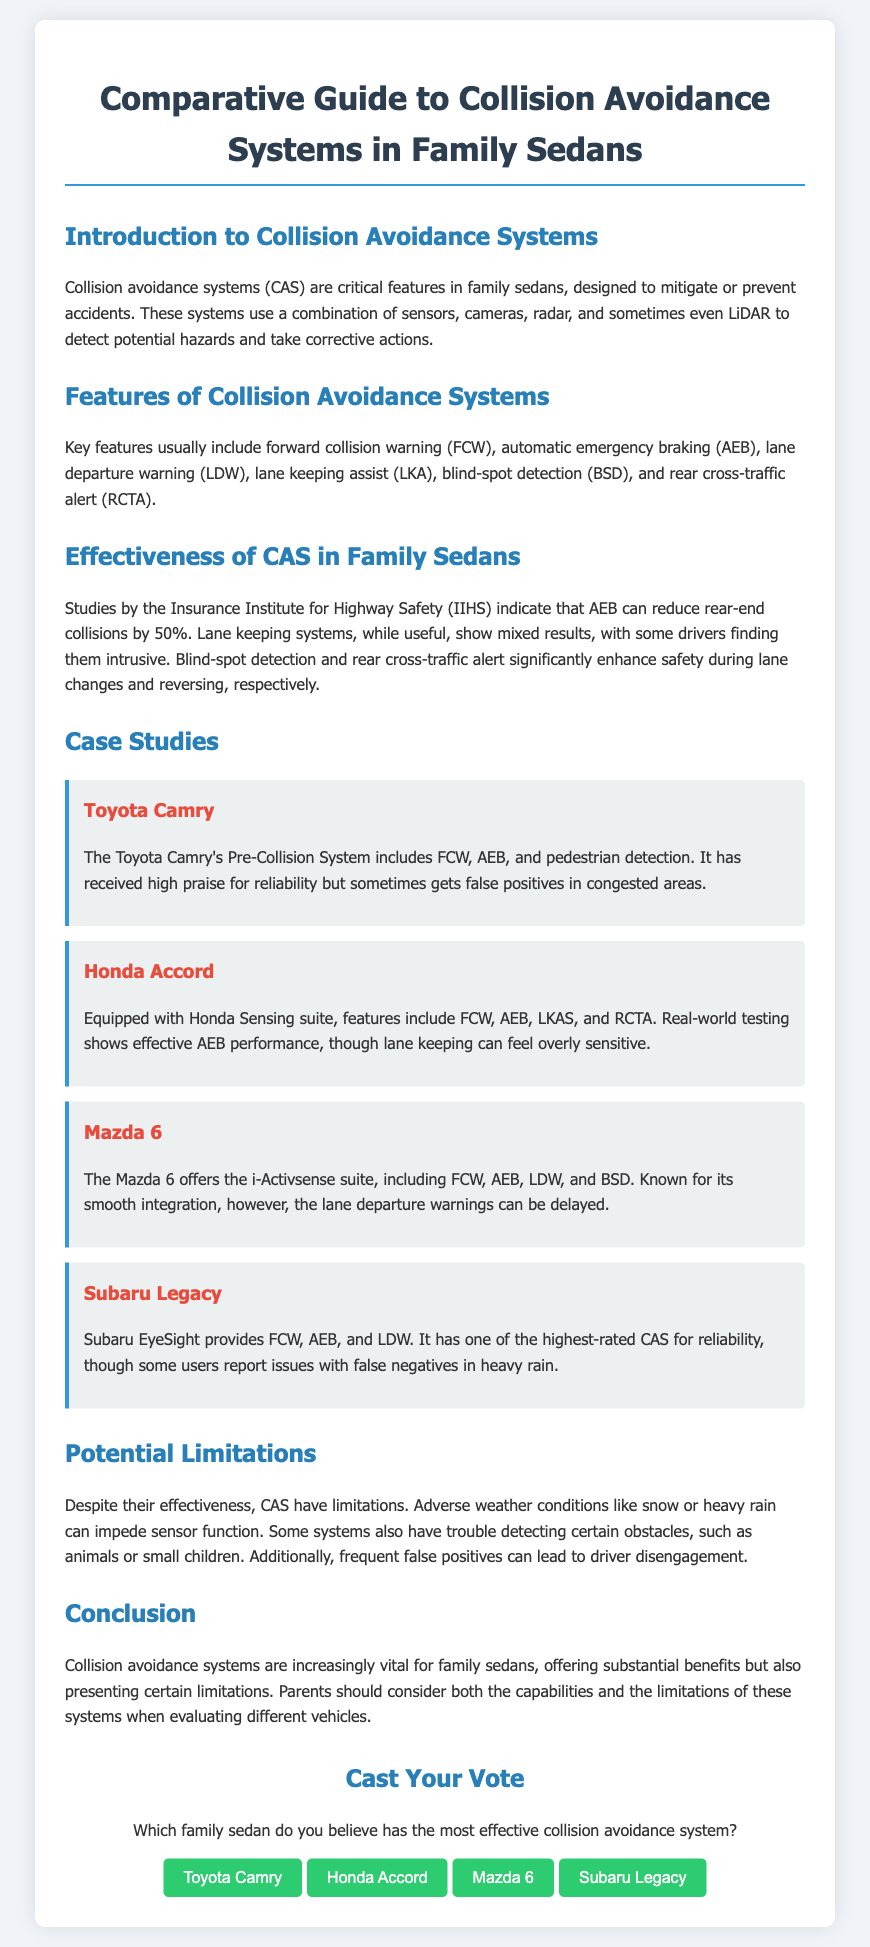What is the main purpose of collision avoidance systems? The document states that collision avoidance systems are designed to mitigate or prevent accidents using sensors, cameras, and radar.
Answer: mitigate or prevent accidents Which system is highlighted for reducing rear-end collisions? The document mentions that AEB can reduce rear-end collisions by 50%, as indicated by the Insurance Institute for Highway Safety.
Answer: AEB What feature is included in the Toyota Camry's Pre-Collision System? The document lists FCW, AEB, and pedestrian detection as features of the Toyota Camry's Pre-Collision System.
Answer: FCW, AEB, and pedestrian detection What limitation is mentioned regarding collision avoidance systems? The document explains that adverse weather conditions like snow or heavy rain can impede sensor function.
Answer: adverse weather conditions Which family sedan has the highest-rated CAS for reliability? According to the document, the Subaru Legacy has one of the highest-rated CAS for reliability.
Answer: Subaru Legacy What is a common driver complaint about lane keeping systems? The document notes that some drivers find lane keeping systems intrusive or overly sensitive.
Answer: intrusive or overly sensitive What is the name of the suite equipped in the Honda Accord? The document refers to the suite in the Honda Accord as Honda Sensing.
Answer: Honda Sensing How many family sedans are compared in this guide? The document discusses four family sedans: Toyota Camry, Honda Accord, Mazda 6, and Subaru Legacy.
Answer: Four 